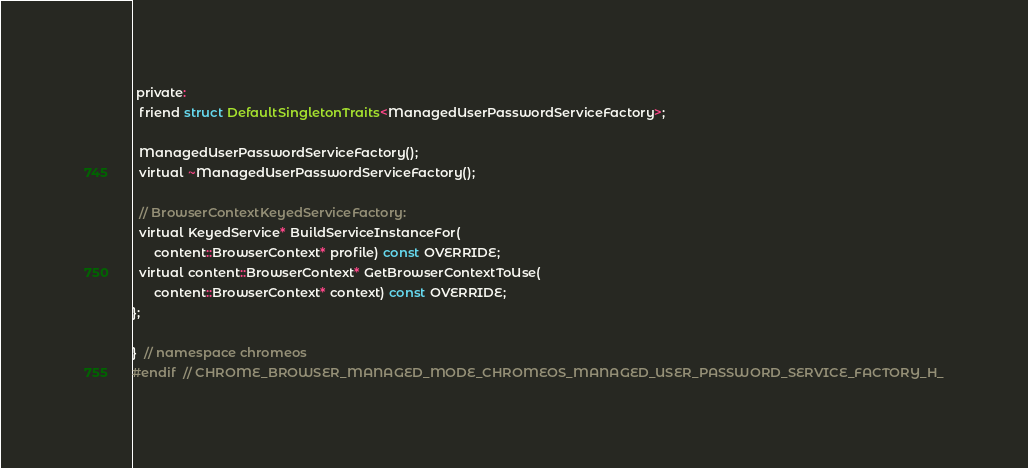Convert code to text. <code><loc_0><loc_0><loc_500><loc_500><_C_> private:
  friend struct DefaultSingletonTraits<ManagedUserPasswordServiceFactory>;

  ManagedUserPasswordServiceFactory();
  virtual ~ManagedUserPasswordServiceFactory();

  // BrowserContextKeyedServiceFactory:
  virtual KeyedService* BuildServiceInstanceFor(
      content::BrowserContext* profile) const OVERRIDE;
  virtual content::BrowserContext* GetBrowserContextToUse(
      content::BrowserContext* context) const OVERRIDE;
};

}  // namespace chromeos
#endif  // CHROME_BROWSER_MANAGED_MODE_CHROMEOS_MANAGED_USER_PASSWORD_SERVICE_FACTORY_H_
</code> 